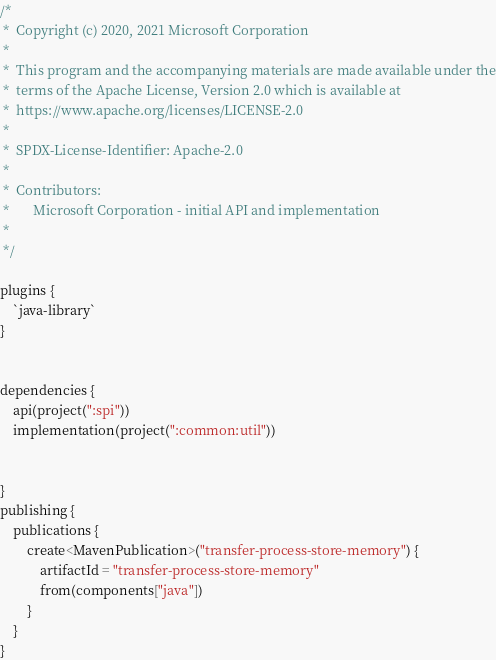<code> <loc_0><loc_0><loc_500><loc_500><_Kotlin_>/*
 *  Copyright (c) 2020, 2021 Microsoft Corporation
 *
 *  This program and the accompanying materials are made available under the
 *  terms of the Apache License, Version 2.0 which is available at
 *  https://www.apache.org/licenses/LICENSE-2.0
 *
 *  SPDX-License-Identifier: Apache-2.0
 *
 *  Contributors:
 *       Microsoft Corporation - initial API and implementation
 *
 */

plugins {
    `java-library`
}


dependencies {
    api(project(":spi"))
    implementation(project(":common:util"))


}
publishing {
    publications {
        create<MavenPublication>("transfer-process-store-memory") {
            artifactId = "transfer-process-store-memory"
            from(components["java"])
        }
    }
}
</code> 